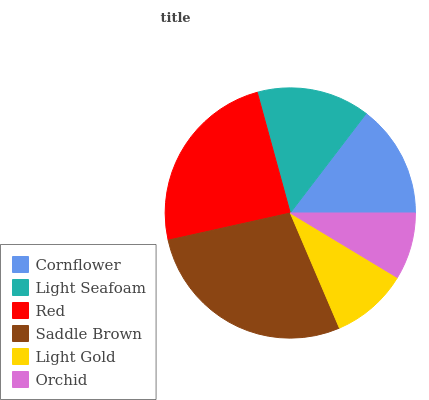Is Orchid the minimum?
Answer yes or no. Yes. Is Saddle Brown the maximum?
Answer yes or no. Yes. Is Light Seafoam the minimum?
Answer yes or no. No. Is Light Seafoam the maximum?
Answer yes or no. No. Is Cornflower greater than Light Seafoam?
Answer yes or no. Yes. Is Light Seafoam less than Cornflower?
Answer yes or no. Yes. Is Light Seafoam greater than Cornflower?
Answer yes or no. No. Is Cornflower less than Light Seafoam?
Answer yes or no. No. Is Cornflower the high median?
Answer yes or no. Yes. Is Light Seafoam the low median?
Answer yes or no. Yes. Is Orchid the high median?
Answer yes or no. No. Is Orchid the low median?
Answer yes or no. No. 